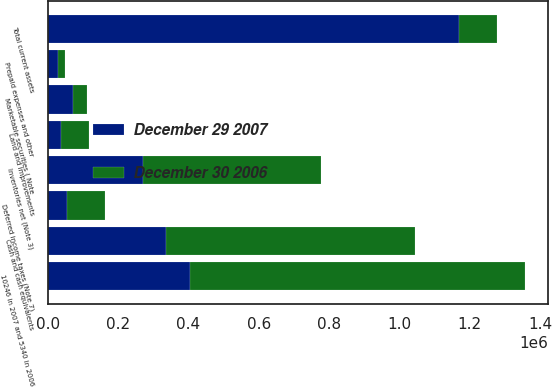Convert chart to OTSL. <chart><loc_0><loc_0><loc_500><loc_500><stacked_bar_chart><ecel><fcel>Cash and cash equivalents<fcel>Marketable securities ( Note<fcel>10246 in 2007 and 5340 in 2006<fcel>Inventories net (Note 3)<fcel>Deferred income taxes (Note 7)<fcel>Prepaid expenses and other<fcel>Total current assets<fcel>Land and improvements<nl><fcel>December 30 2006<fcel>707689<fcel>37551<fcel>952513<fcel>505467<fcel>107376<fcel>22179<fcel>107376<fcel>79445<nl><fcel>December 29 2007<fcel>337321<fcel>73033<fcel>403524<fcel>271008<fcel>55996<fcel>28202<fcel>1.16908e+06<fcel>37103<nl></chart> 